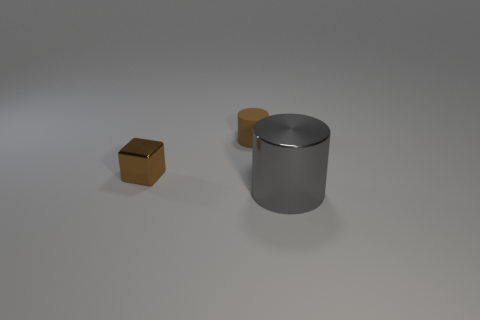Add 3 small red shiny cubes. How many objects exist? 6 Subtract all cylinders. How many objects are left? 1 Add 1 brown metallic objects. How many brown metallic objects are left? 2 Add 3 rubber cylinders. How many rubber cylinders exist? 4 Subtract all gray cylinders. How many cylinders are left? 1 Subtract 0 yellow cylinders. How many objects are left? 3 Subtract 1 cubes. How many cubes are left? 0 Subtract all gray blocks. Subtract all blue spheres. How many blocks are left? 1 Subtract all blue blocks. How many green cylinders are left? 0 Subtract all big shiny cylinders. Subtract all purple matte spheres. How many objects are left? 2 